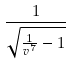<formula> <loc_0><loc_0><loc_500><loc_500>\frac { 1 } { \sqrt { \frac { 1 } { v ^ { 7 } } - 1 } }</formula> 